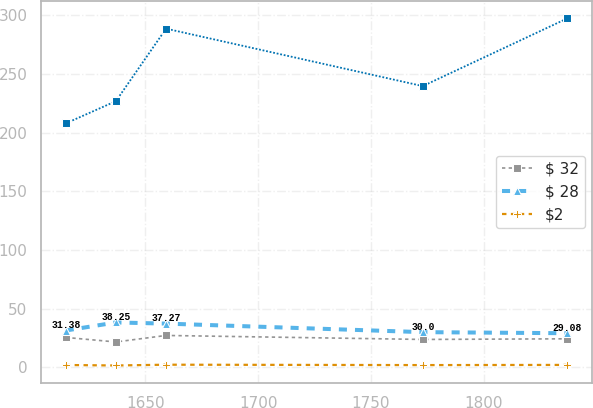Convert chart. <chart><loc_0><loc_0><loc_500><loc_500><line_chart><ecel><fcel>Unnamed: 1<fcel>$ 32<fcel>$ 28<fcel>$2<nl><fcel>1614.72<fcel>207.73<fcel>25.49<fcel>31.38<fcel>2.02<nl><fcel>1636.96<fcel>226.7<fcel>21.64<fcel>38.25<fcel>1.61<nl><fcel>1659.2<fcel>288.43<fcel>27.18<fcel>37.27<fcel>2.28<nl><fcel>1773<fcel>239.51<fcel>23.78<fcel>30<fcel>1.95<nl><fcel>1837.08<fcel>297.16<fcel>24.33<fcel>29.08<fcel>2.1<nl></chart> 